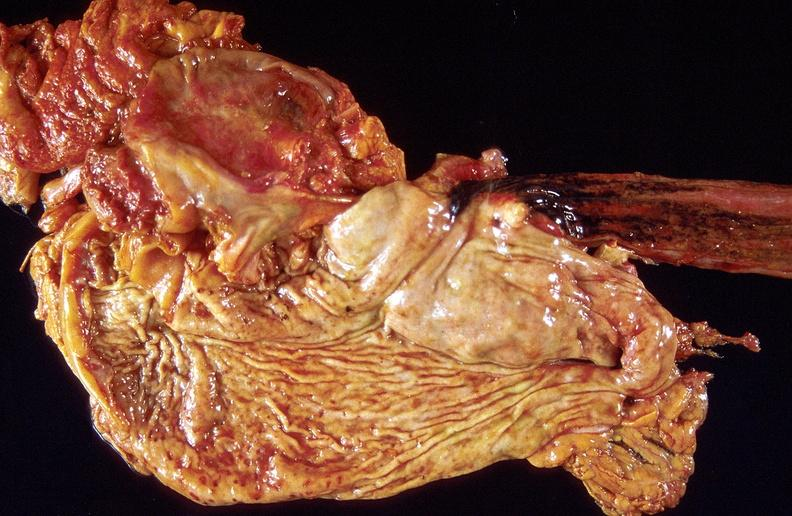what is present?
Answer the question using a single word or phrase. Gastrointestinal 